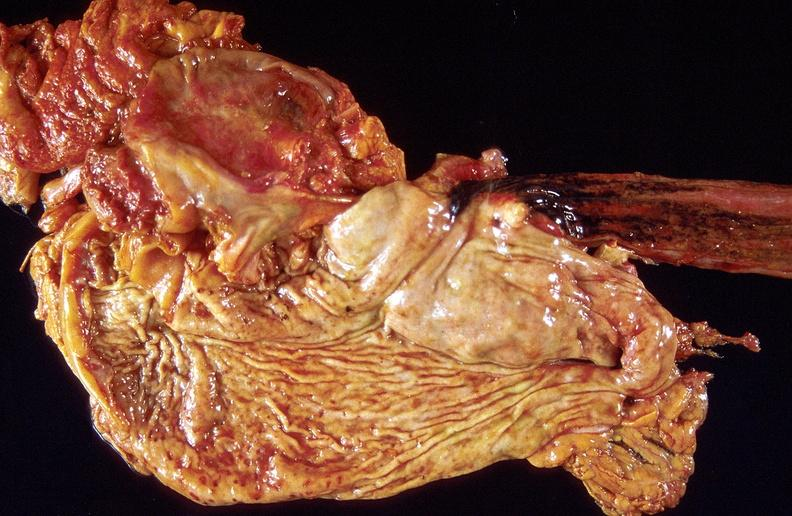what is present?
Answer the question using a single word or phrase. Gastrointestinal 